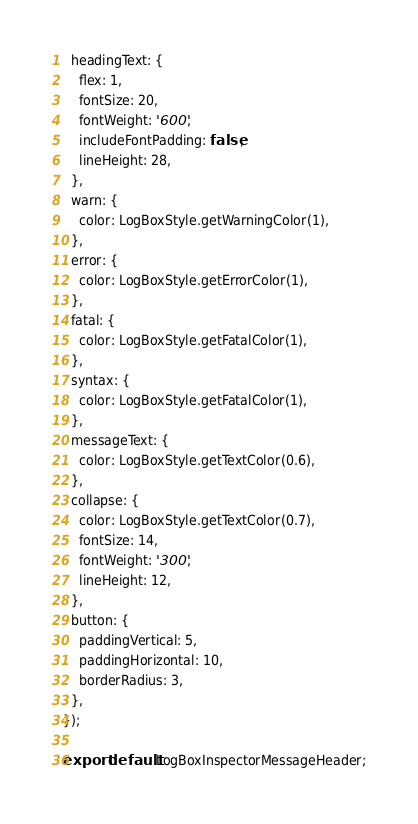<code> <loc_0><loc_0><loc_500><loc_500><_JavaScript_>  headingText: {
    flex: 1,
    fontSize: 20,
    fontWeight: '600',
    includeFontPadding: false,
    lineHeight: 28,
  },
  warn: {
    color: LogBoxStyle.getWarningColor(1),
  },
  error: {
    color: LogBoxStyle.getErrorColor(1),
  },
  fatal: {
    color: LogBoxStyle.getFatalColor(1),
  },
  syntax: {
    color: LogBoxStyle.getFatalColor(1),
  },
  messageText: {
    color: LogBoxStyle.getTextColor(0.6),
  },
  collapse: {
    color: LogBoxStyle.getTextColor(0.7),
    fontSize: 14,
    fontWeight: '300',
    lineHeight: 12,
  },
  button: {
    paddingVertical: 5,
    paddingHorizontal: 10,
    borderRadius: 3,
  },
});

export default LogBoxInspectorMessageHeader;
</code> 